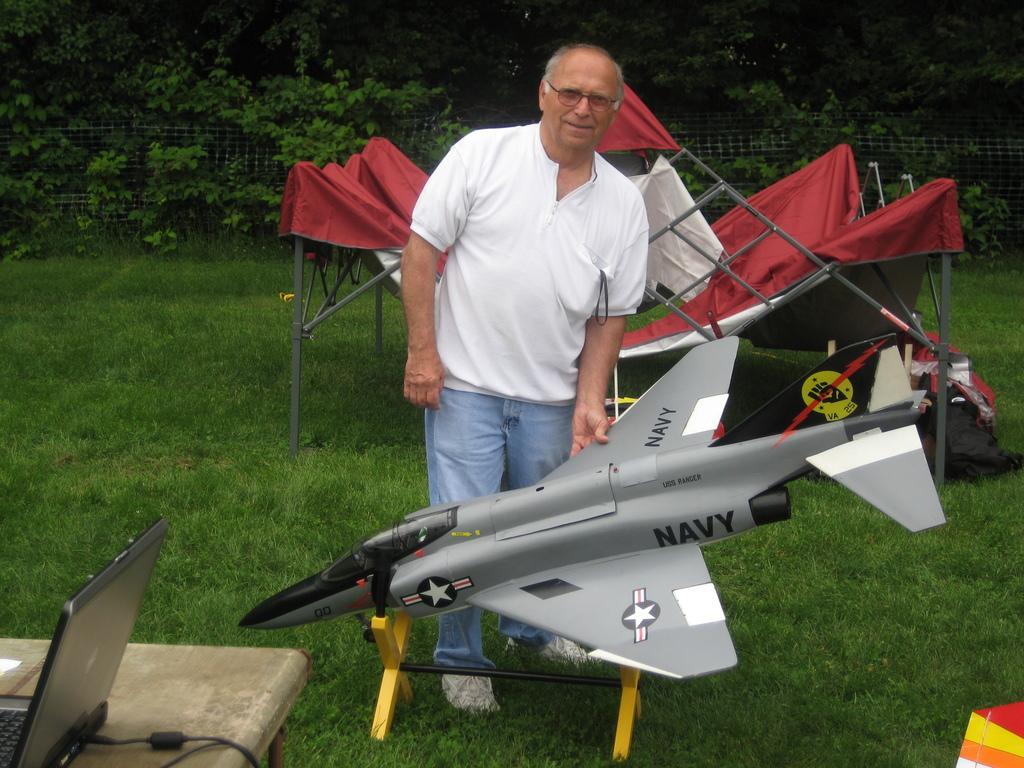Please provide a concise description of this image. In the center of the image we can see a man standing. At the bottom there is a toy aeroplane. On the left there is a table and we can see a laptop placed on the table. At the bottom there is grass. In the background there is a tent, trees and a mesh. 